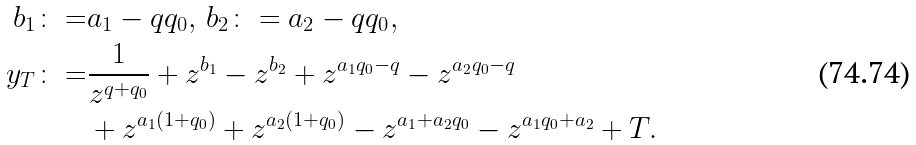Convert formula to latex. <formula><loc_0><loc_0><loc_500><loc_500>b _ { 1 } \colon = & a _ { 1 } - q q _ { 0 } , \, b _ { 2 } \colon = a _ { 2 } - q q _ { 0 } , \\ y _ { T } \colon = & \frac { 1 } { z ^ { q + q _ { 0 } } } + z ^ { b _ { 1 } } - z ^ { b _ { 2 } } + z ^ { a _ { 1 } q _ { 0 } - q } - z ^ { a _ { 2 } q _ { 0 } - q } \\ & + z ^ { a _ { 1 } ( 1 + q _ { 0 } ) } + z ^ { a _ { 2 } ( 1 + q _ { 0 } ) } - z ^ { a _ { 1 } + a _ { 2 } q _ { 0 } } - z ^ { a _ { 1 } q _ { 0 } + a _ { 2 } } + T .</formula> 